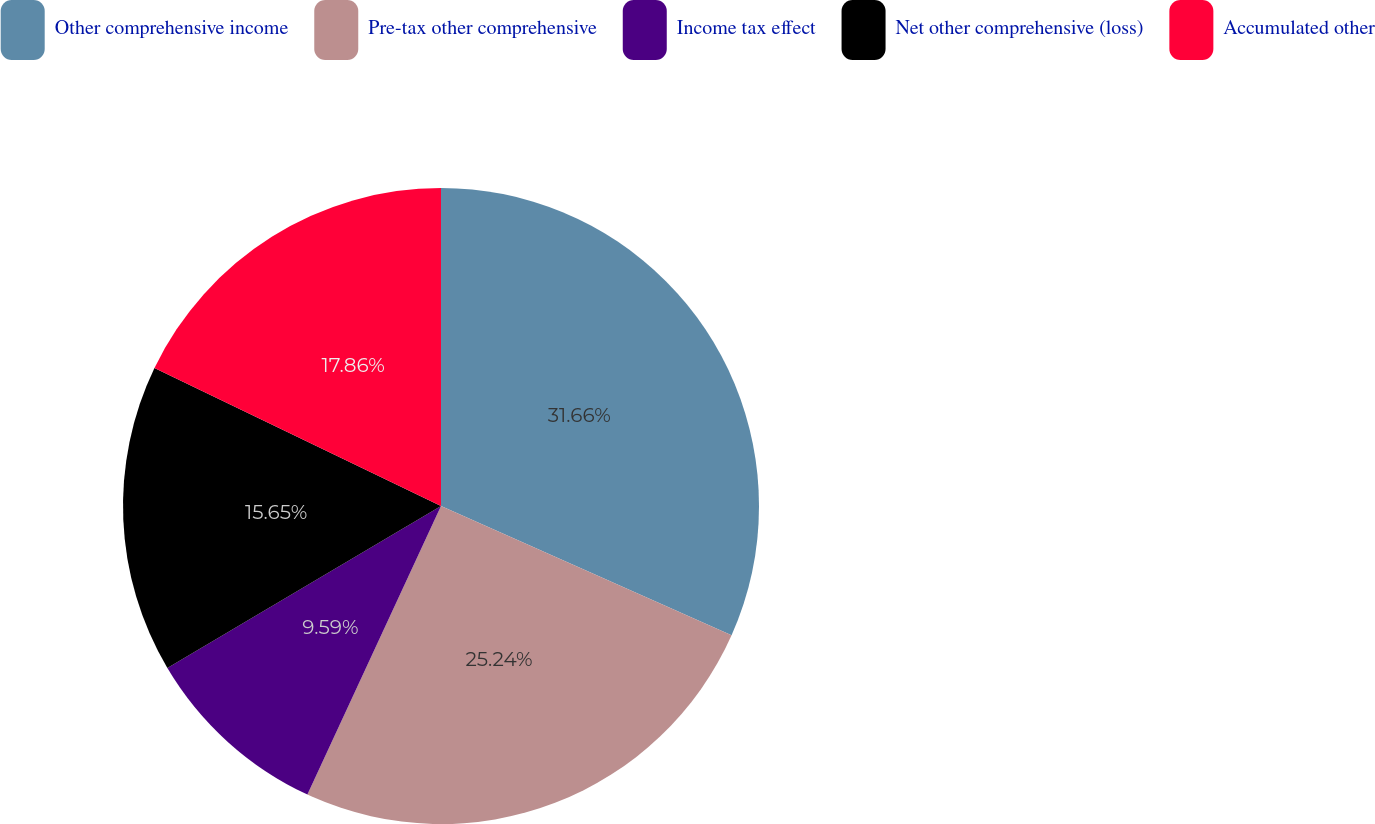Convert chart to OTSL. <chart><loc_0><loc_0><loc_500><loc_500><pie_chart><fcel>Other comprehensive income<fcel>Pre-tax other comprehensive<fcel>Income tax effect<fcel>Net other comprehensive (loss)<fcel>Accumulated other<nl><fcel>31.66%<fcel>25.24%<fcel>9.59%<fcel>15.65%<fcel>17.86%<nl></chart> 